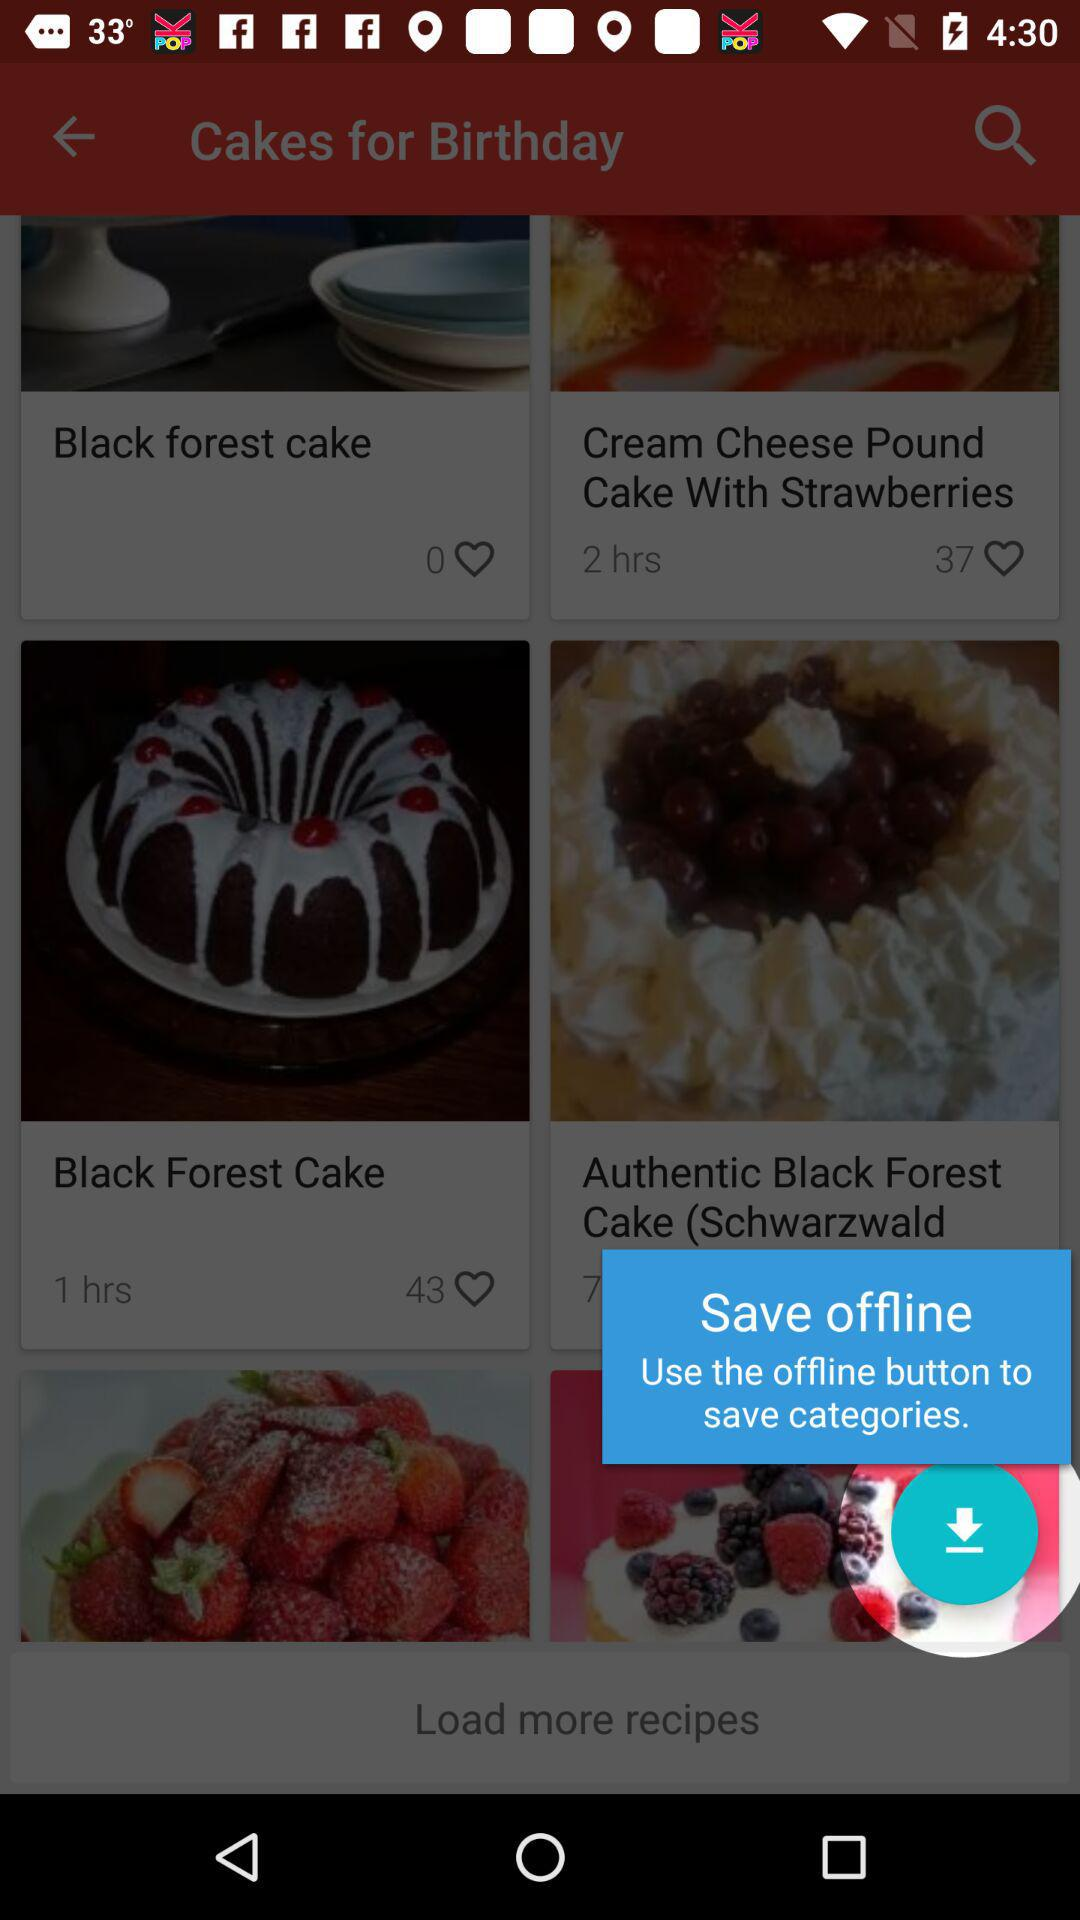How many likes are there of "Cream Cheese Pound Cake With Strawberries"? There are 37 likes. 